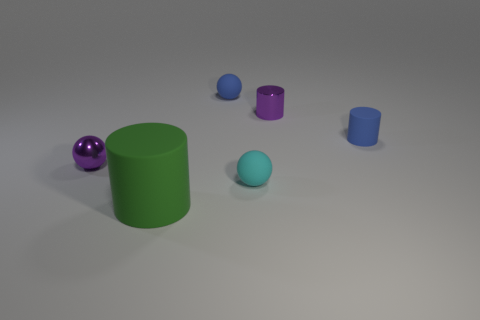Subtract all small shiny spheres. How many spheres are left? 2 Subtract all blue cylinders. How many cylinders are left? 2 Add 3 small blue balls. How many objects exist? 9 Subtract all brown cubes. How many red spheres are left? 0 Subtract 0 cyan cylinders. How many objects are left? 6 Subtract all red balls. Subtract all purple blocks. How many balls are left? 3 Subtract all large green cylinders. Subtract all tiny purple shiny spheres. How many objects are left? 4 Add 5 small blue matte balls. How many small blue matte balls are left? 6 Add 4 small cyan spheres. How many small cyan spheres exist? 5 